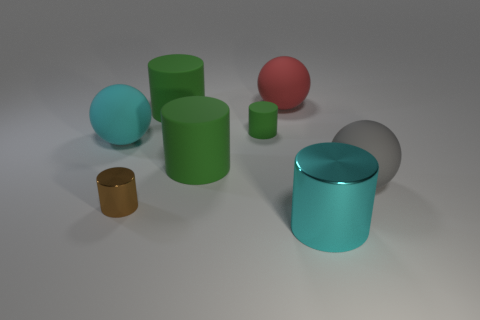What number of red blocks are made of the same material as the large red ball?
Offer a very short reply. 0. How many gray things are behind the big gray thing on the right side of the small brown cylinder?
Your response must be concise. 0. Is the color of the rubber ball in front of the large cyan ball the same as the metal thing that is right of the red matte ball?
Your answer should be compact. No. What shape is the large rubber object that is right of the small green matte object and on the left side of the big gray ball?
Your response must be concise. Sphere. Is there another tiny brown thing that has the same shape as the brown object?
Give a very brief answer. No. There is another metallic object that is the same size as the red object; what shape is it?
Offer a very short reply. Cylinder. What is the large cyan sphere made of?
Your answer should be compact. Rubber. There is a metal cylinder that is left of the cylinder that is in front of the metallic cylinder that is behind the big cyan metallic cylinder; what is its size?
Your answer should be very brief. Small. What is the material of the sphere that is the same color as the large metallic object?
Your answer should be very brief. Rubber. What number of rubber objects are big green cylinders or big green balls?
Provide a short and direct response. 2. 